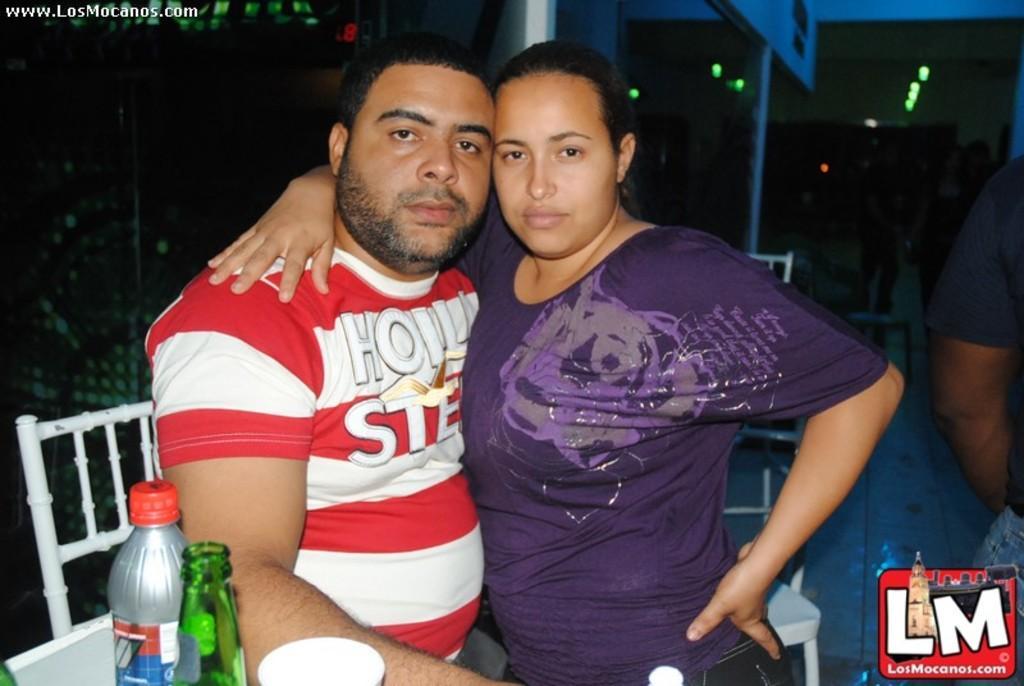Could you give a brief overview of what you see in this image? In this image there are two persons, there are bottles and a glass on the table, there are chairs, and in the background there are group of people standing , and there are watermarks on the image. 